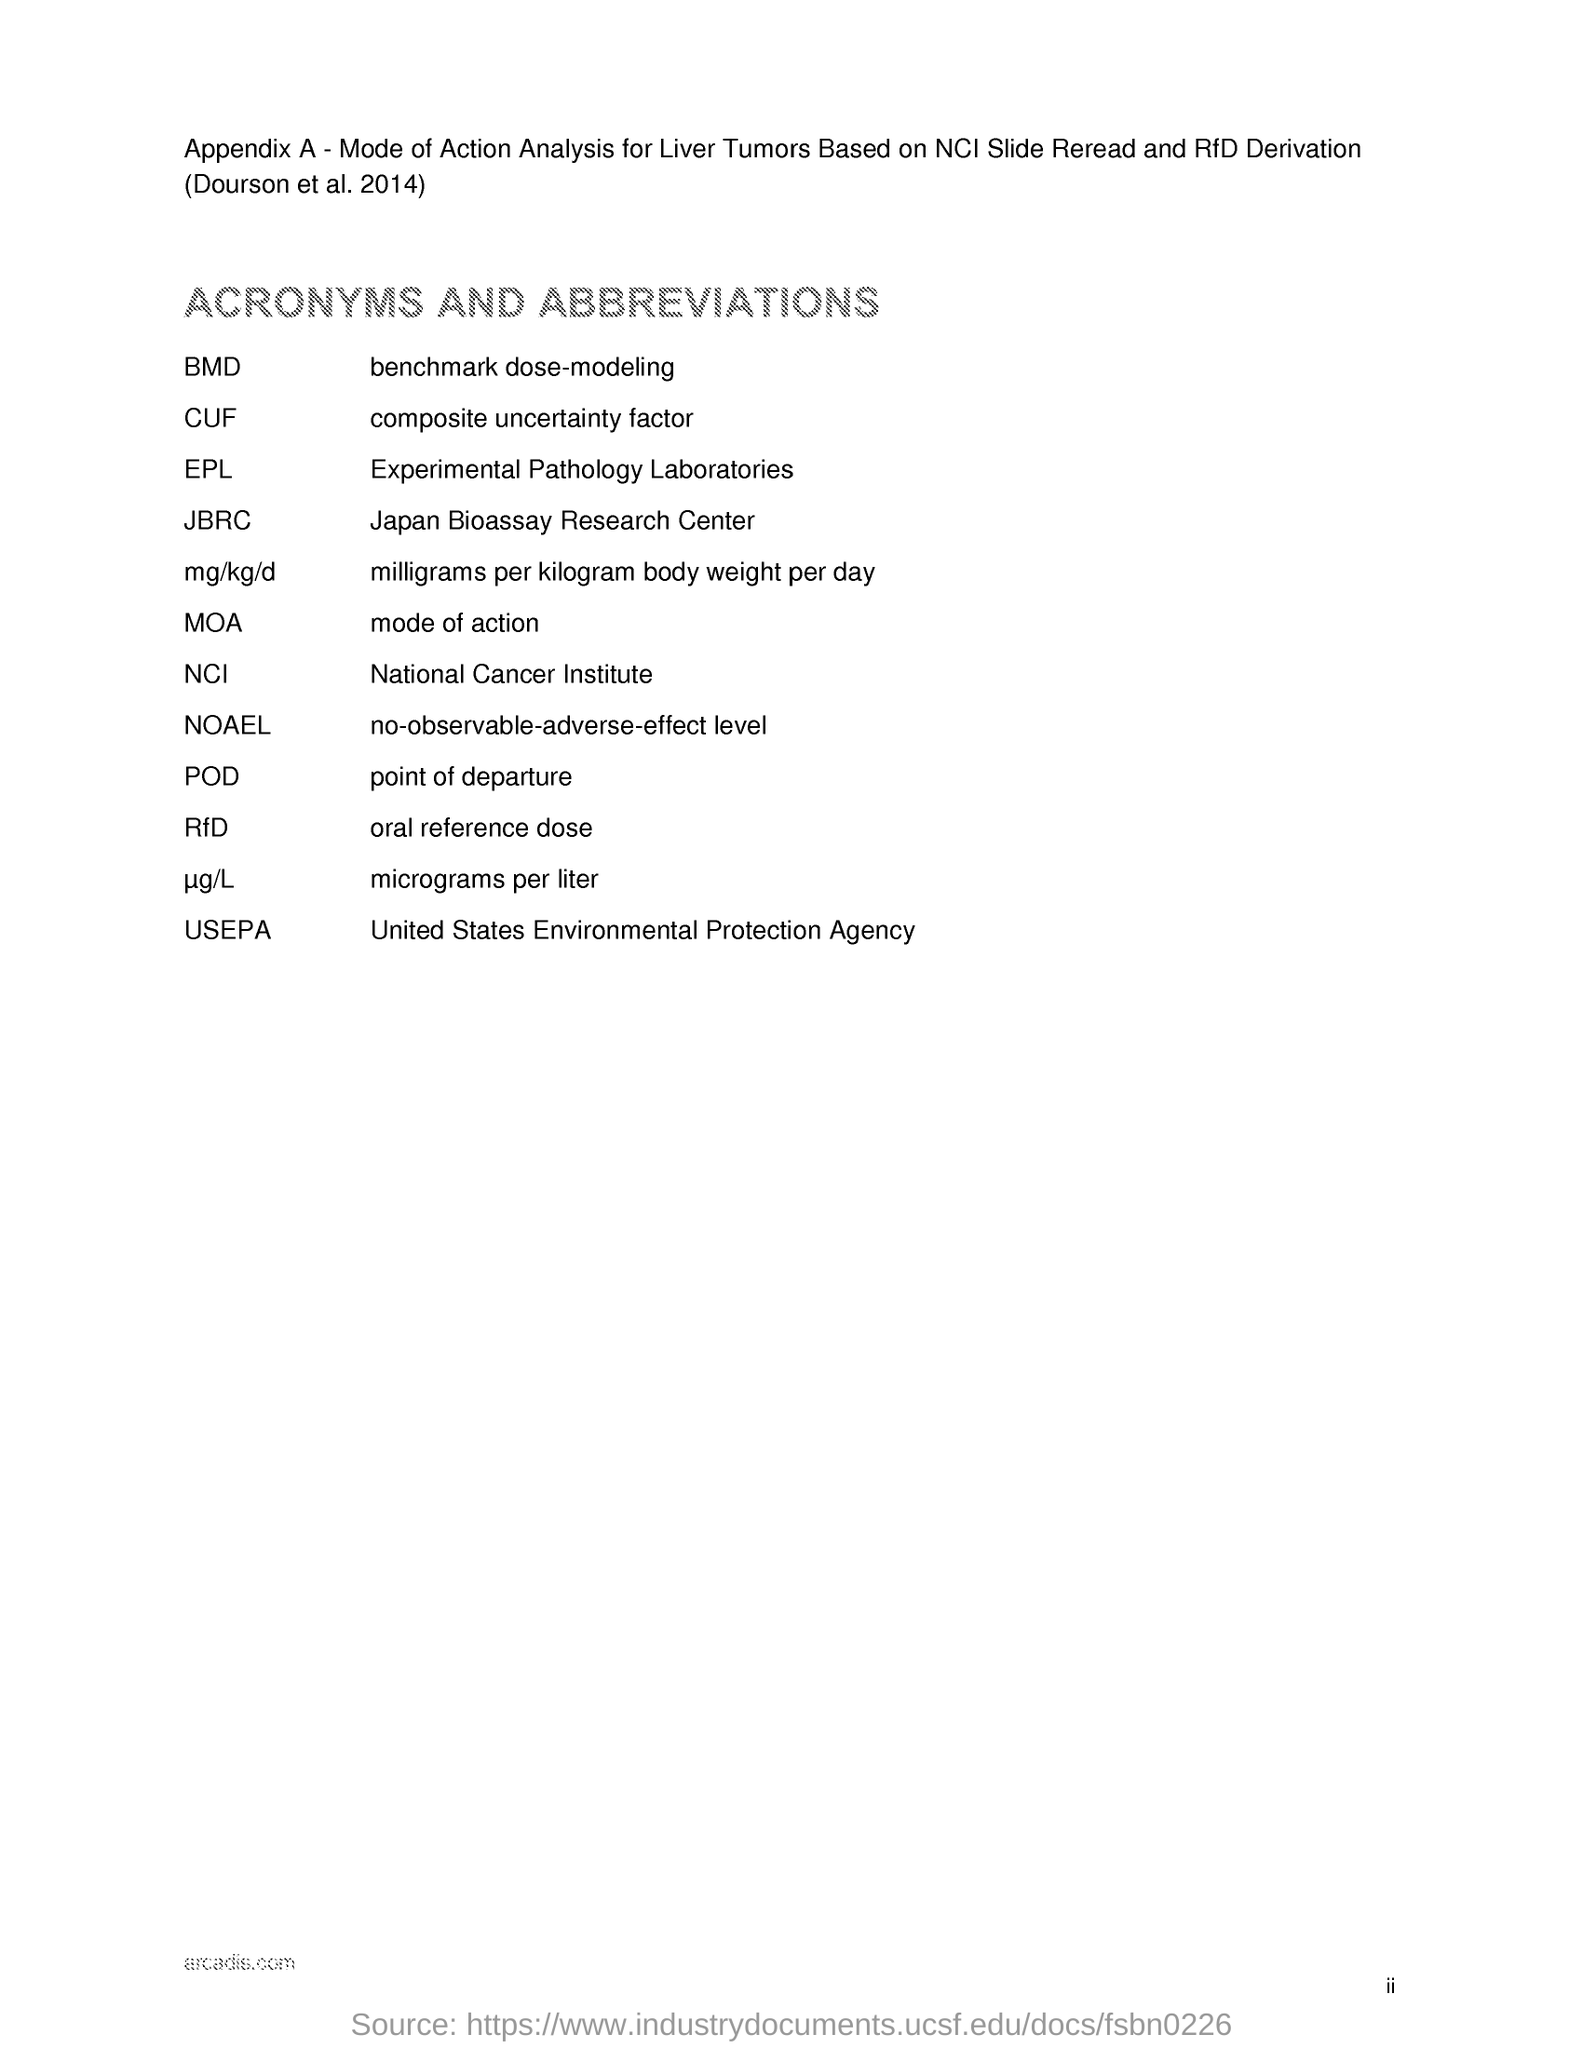Indicate a few pertinent items in this graphic. The document titled "Appendix A: Mode of Action Analysis for Liver Tumors Based on NCI Slide Reread and RfD Derivation" provides a detailed analysis of the mechanism by which liver tumors develop and the potential risks associated with exposure to certain substances. 